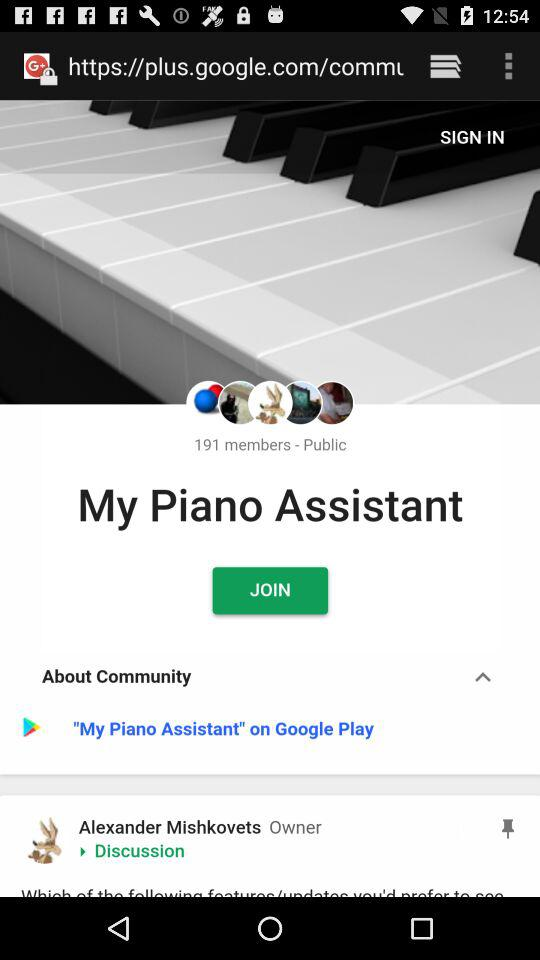Who is the owner of "My Piano Assistant"? The owner of "My Piano Assistant" is Alexander Mishkovets. 